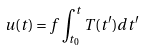<formula> <loc_0><loc_0><loc_500><loc_500>u ( t ) = f \int _ { t _ { 0 } } ^ { t } T ( t ^ { \prime } ) d t ^ { \prime }</formula> 